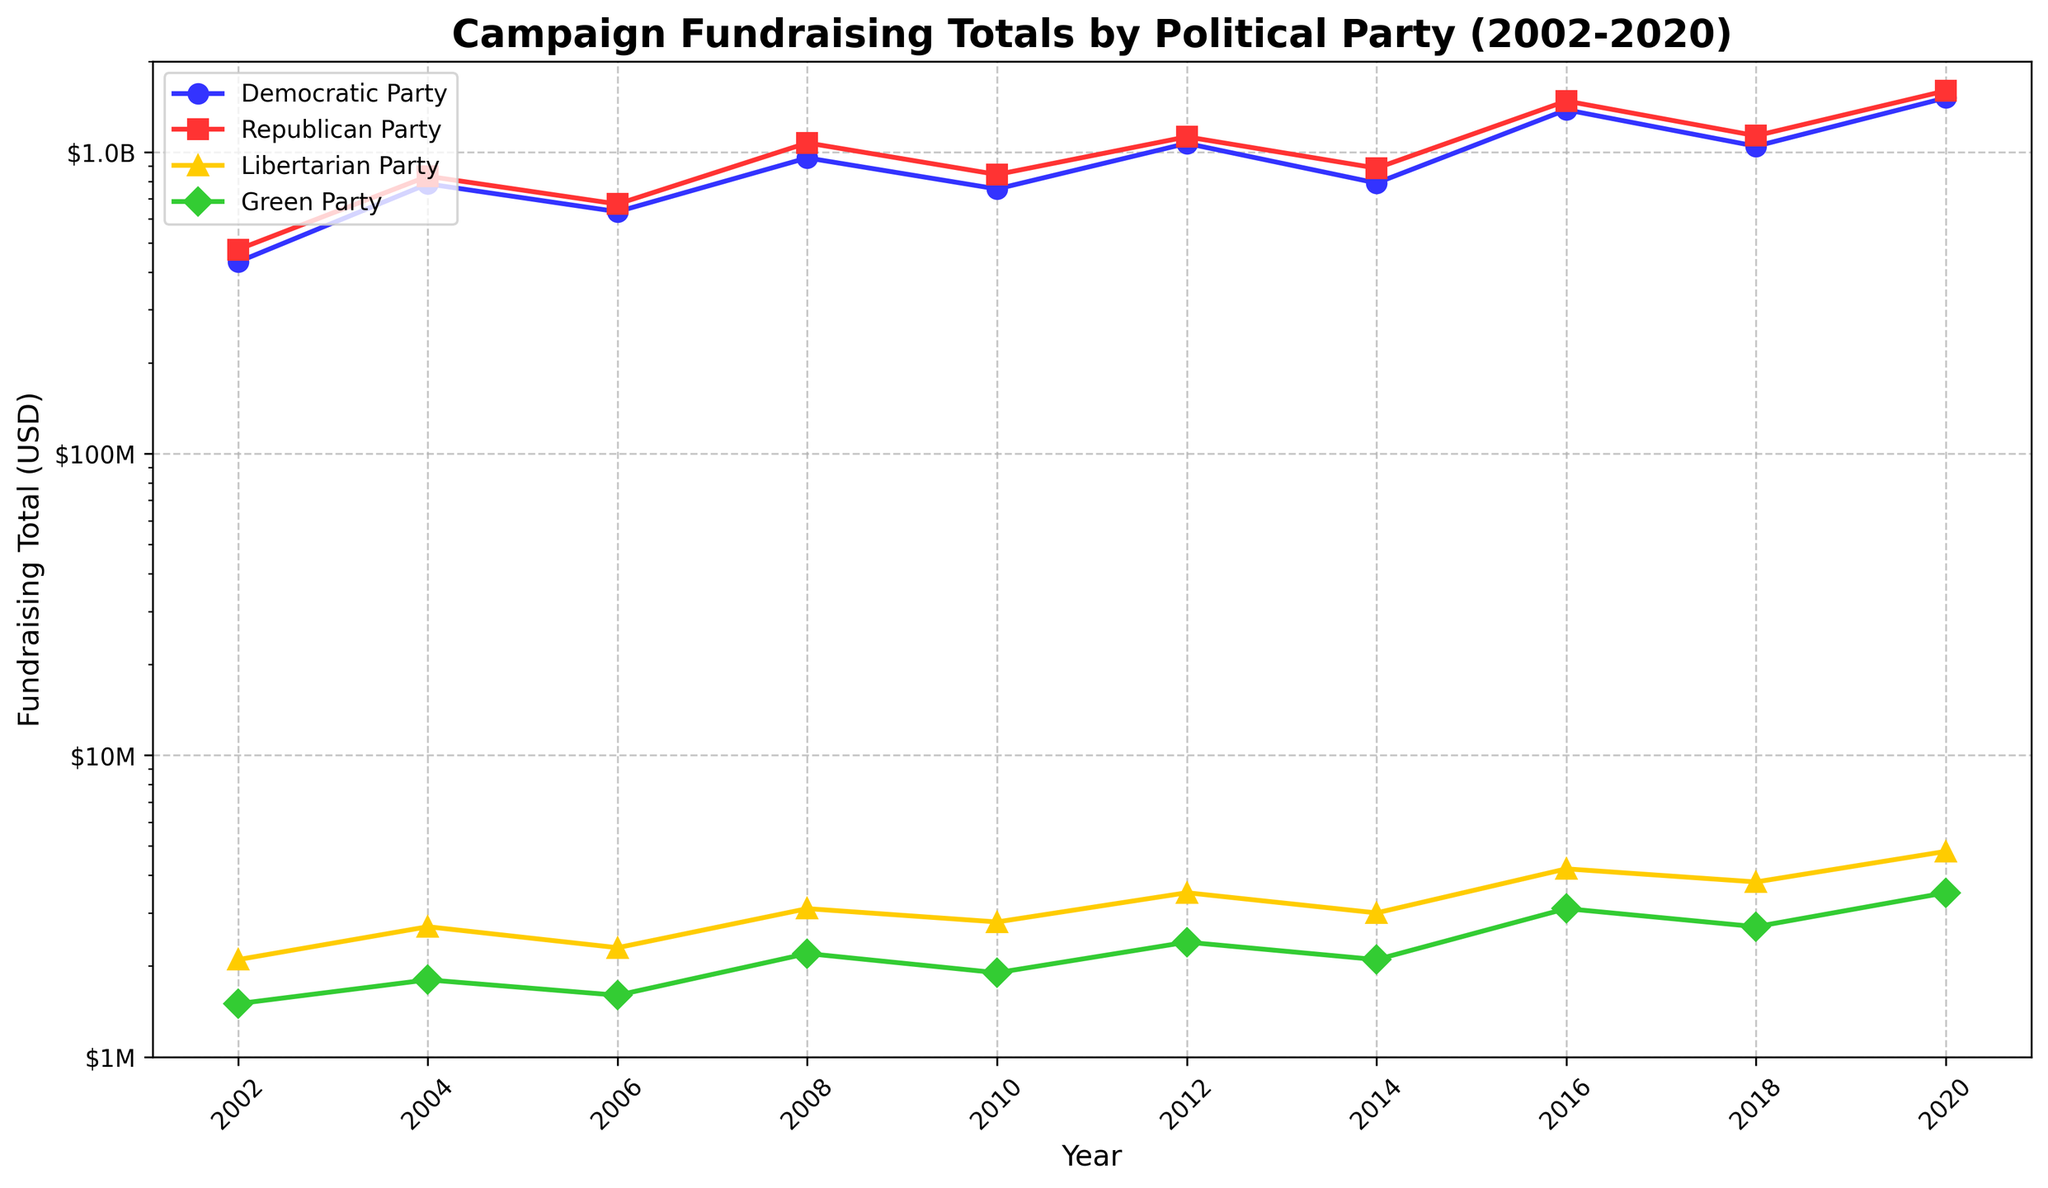What was the total fundraising amount for the Democratic Party in 2020, and how does it compare to the total amount in 2002? Look at the Democratic Party's fundraising totals for 2020 and 2002 on the chart. Democratic Party raised $1,512,000,000 in 2020 and $432,000,000 in 2002. The comparison is calculated as $1,512,000,000 - $432,000,000 = $1,080,000,000.
Answer: $1,080,000,000 more in 2020 Which party had the highest fundraising total in 2020, and what was the amount raised by that party? Examine the data plot for 2020. The Republican Party is shown to have the highest fundraising total among the parties.
Answer: Republican Party, $1,596,000,000 How did the Libertarian Party's fundraising totals change from 2008 to 2016? Check the values for the Libertarian Party in both 2008 and 2016. In 2008, Libertarian Party raised $3,100,000; in 2016, they raised $4,200,000. The difference is $4,200,000 - $3,100,000 = $1,100,000.
Answer: Increased by $1,100,000 What is the overall trend for the Green Party's fundraising from 2002 to 2020? Observe the line plot for the Green Party from 2002 to 2020. The overall trend is an increase. The values were $1,500,000 in 2002 and $3,500,000 in 2020.
Answer: Increasing Which election year shows a noticeable dip in fundraising for both major parties (Democratic and Republican)? Look for the year where both lines dip. Both Democratic and Republican Parties show a dip in 2014.
Answer: 2014 What was the average fundraising total for the Democratic Party over the 10 election cycles? Add up all the Democratic Party fundraising totals and then divide by the number of years (10). The total is ($432,000,000 + $784,000,000 + $634,000,000 + $956,000,000 + $754,000,000 + $1,068,000,000 + $789,000,000 + $1,380,000,000 + $1,045,000,000 + $1,512,000,000) = $9,354,000,000. The average is $9,354,000,000 / 10 = $935,400,000.
Answer: $935,400,000 In which years did the fundraising totals of the Green Party exceed that of the Libertarian Party? Compare the values of Green and Libertarian Parties year by year. The Green Party had lower fundraising totals than the Libertarian Party in all given years.
Answer: None How does the Republican Party's fundraising total in 2016 compare to the Democratic Party's total in the same year? Look at both parties' fundraising totals in 2016. Republican Party raised $1,476,000,000 and Democratic Party raised $1,380,000,000. The difference is $1,476,000,000 - $1,380,000,000 = $96,000,000.
Answer: $96,000,000 more for Republican Party Which party showed the least fundraising variability over the period from 2002 to 2020? Observe the fluctuations in the lines for each party. The Libertarian Party's line is the flattest, indicating the least variability.
Answer: Libertarian Party 